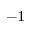<formula> <loc_0><loc_0><loc_500><loc_500>^ { - 1 }</formula> 